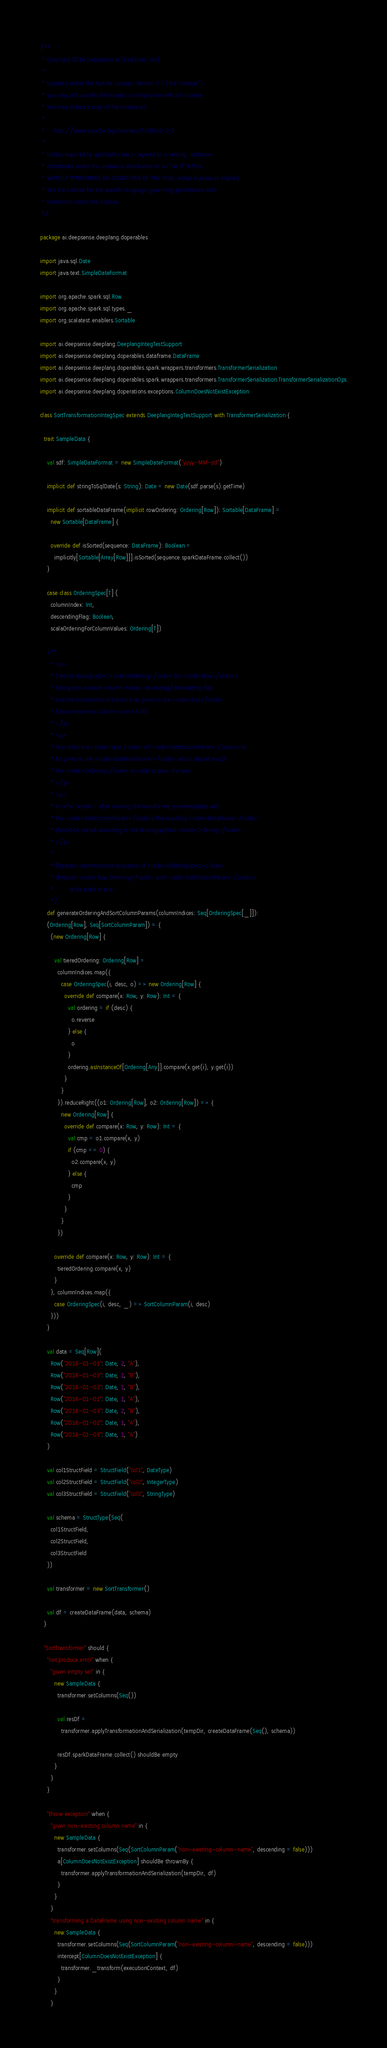Convert code to text. <code><loc_0><loc_0><loc_500><loc_500><_Scala_>/**
 * Copyright 2016 deepsense.ai (CodiLime, Inc)
 *
 * Licensed under the Apache License, Version 2.0 (the "License");
 * you may not use this file except in compliance with the License.
 * You may obtain a copy of the License at
 *
 *     http://www.apache.org/licenses/LICENSE-2.0
 *
 * Unless required by applicable law or agreed to in writing, software
 * distributed under the License is distributed on an "AS IS" BASIS,
 * WITHOUT WARRANTIES OR CONDITIONS OF ANY KIND, either express or implied.
 * See the License for the specific language governing permissions and
 * limitations under the License.
 */

package ai.deepsense.deeplang.doperables

import java.sql.Date
import java.text.SimpleDateFormat

import org.apache.spark.sql.Row
import org.apache.spark.sql.types._
import org.scalatest.enablers.Sortable

import ai.deepsense.deeplang.DeeplangIntegTestSupport
import ai.deepsense.deeplang.doperables.dataframe.DataFrame
import ai.deepsense.deeplang.doperables.spark.wrappers.transformers.TransformerSerialization
import ai.deepsense.deeplang.doperables.spark.wrappers.transformers.TransformerSerialization.TransformerSerializationOps
import ai.deepsense.deeplang.doperations.exceptions.ColumnDoesNotExistException

class SortTransformationIntegSpec extends DeeplangIntegTestSupport with TransformerSerialization {

  trait SampleData {

    val sdf: SimpleDateFormat = new SimpleDateFormat("yyyy-MM-dd")

    implicit def stringToSqlDate(s: String): Date = new Date(sdf.parse(s).getTime)

    implicit def sortableDataFrame(implicit rowOrdering: Ordering[Row]): Sortable[DataFrame] =
      new Sortable[DataFrame] {

      override def isSorted(sequence: DataFrame): Boolean =
        implicitly[Sortable[Array[Row]]].isSorted(sequence.sparkDataFrame.collect())
    }

    case class OrderingSpec[T] (
      columnIndex: Int,
      descendingFlag: Boolean,
      scalaOrderingForColumnValues: Ordering[T])

    /**
      * <p>
      * Creates lexicographic <code>Ordering</code> for <code>Row</code>s
      * taking into account column indices, ascending/descending flag
      * and the importance of columns as given in the <code>Seq</code>
      * (more important columns come first).
      * </p>
      * <p>
      * Also returns a <code>Seq</code> of <code>SortColumnParam</code>s to
      * be given to the <code>SortTransformer</code> which should match
      * the <code>Ordering</code> in order to pass the test.
      * </p>
      * <p>
      * In other words - after running the transformer parameterized with
      * the <code>SortColumnParam</code>s the resulting <code>DataFrame</code>
      * should be sorted according to the lexicographical <code>Ordering</code>.
      * </p>
      *
      * @param columnIndices sequence of <code>OrderingSpecs</code>
      * @return <code>Row Ordering</code> and <code>SortColumnParam</code>s
      *         to be used in test
      */
    def generateOrderingAndSortColumnParams(columnIndices: Seq[OrderingSpec[_]]):
    (Ordering[Row], Seq[SortColumnParam]) = {
      (new Ordering[Row] {

        val tieredOrdering: Ordering[Row] =
          columnIndices.map({
            case OrderingSpec(i, desc, o) => new Ordering[Row] {
              override def compare(x: Row, y: Row): Int = {
                val ordering = if (desc) {
                  o.reverse
                } else {
                  o
                }
                ordering.asInstanceOf[Ordering[Any]].compare(x.get(i), y.get(i))
              }
            }
          }).reduceRight((o1: Ordering[Row], o2: Ordering[Row]) => {
            new Ordering[Row] {
              override def compare(x: Row, y: Row): Int = {
                val cmp = o1.compare(x, y)
                if (cmp == 0) {
                  o2.compare(x, y)
                } else {
                  cmp
                }
              }
            }
          })

        override def compare(x: Row, y: Row): Int = {
          tieredOrdering.compare(x, y)
        }
      }, columnIndices.map({
        case OrderingSpec(i, desc, _) => SortColumnParam(i, desc)
      }))
    }

    val data = Seq[Row](
      Row("2016-01-01": Date, 2, "A"),
      Row("2016-01-03": Date, 1, "B"),
      Row("2016-01-02": Date, 1, "B"),
      Row("2016-01-01": Date, 1, "A"),
      Row("2016-01-03": Date, 2, "B"),
      Row("2016-01-02": Date, 1, "A"),
      Row("2016-01-03": Date, 1, "A")
    )

    val col1StructField = StructField("col1", DateType)
    val col2StructField = StructField("col2", IntegerType)
    val col3StructField = StructField("col3", StringType)

    val schema = StructType(Seq(
      col1StructField,
      col2StructField,
      col3StructField
    ))

    val transformer = new SortTransformer()

    val df = createDataFrame(data, schema)
  }

  "SortTransformer" should {
    "not produce error" when {
      "given empty set" in {
        new SampleData {
          transformer.setColumns(Seq())

          val resDf =
            transformer.applyTransformationAndSerialization(tempDir, createDataFrame(Seq(), schema))

          resDf.sparkDataFrame.collect() shouldBe empty
        }
      }
    }

    "throw exception" when {
      "given non-existing column name" in {
        new SampleData {
          transformer.setColumns(Seq(SortColumnParam("non-existing-column-name", descending = false)))
          a[ColumnDoesNotExistException] shouldBe thrownBy {
            transformer.applyTransformationAndSerialization(tempDir, df)
          }
        }
      }
      "transforming a DataFrame using non-existing column name" in {
        new SampleData {
          transformer.setColumns(Seq(SortColumnParam("non-existing-column-name", descending = false)))
          intercept[ColumnDoesNotExistException] {
            transformer._transform(executionContext, df)
          }
        }
      }</code> 